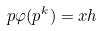<formula> <loc_0><loc_0><loc_500><loc_500>p \varphi ( p ^ { k } ) = x h</formula> 